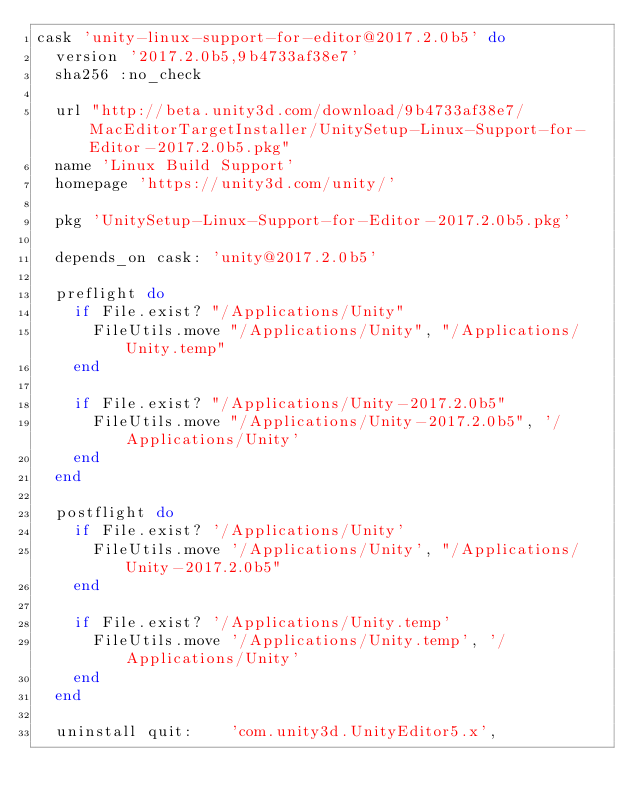Convert code to text. <code><loc_0><loc_0><loc_500><loc_500><_Ruby_>cask 'unity-linux-support-for-editor@2017.2.0b5' do
  version '2017.2.0b5,9b4733af38e7'
  sha256 :no_check

  url "http://beta.unity3d.com/download/9b4733af38e7/MacEditorTargetInstaller/UnitySetup-Linux-Support-for-Editor-2017.2.0b5.pkg"
  name 'Linux Build Support'
  homepage 'https://unity3d.com/unity/'

  pkg 'UnitySetup-Linux-Support-for-Editor-2017.2.0b5.pkg'

  depends_on cask: 'unity@2017.2.0b5'

  preflight do
    if File.exist? "/Applications/Unity"
      FileUtils.move "/Applications/Unity", "/Applications/Unity.temp"
    end

    if File.exist? "/Applications/Unity-2017.2.0b5"
      FileUtils.move "/Applications/Unity-2017.2.0b5", '/Applications/Unity'
    end
  end

  postflight do
    if File.exist? '/Applications/Unity'
      FileUtils.move '/Applications/Unity', "/Applications/Unity-2017.2.0b5"
    end

    if File.exist? '/Applications/Unity.temp'
      FileUtils.move '/Applications/Unity.temp', '/Applications/Unity'
    end
  end

  uninstall quit:    'com.unity3d.UnityEditor5.x',</code> 